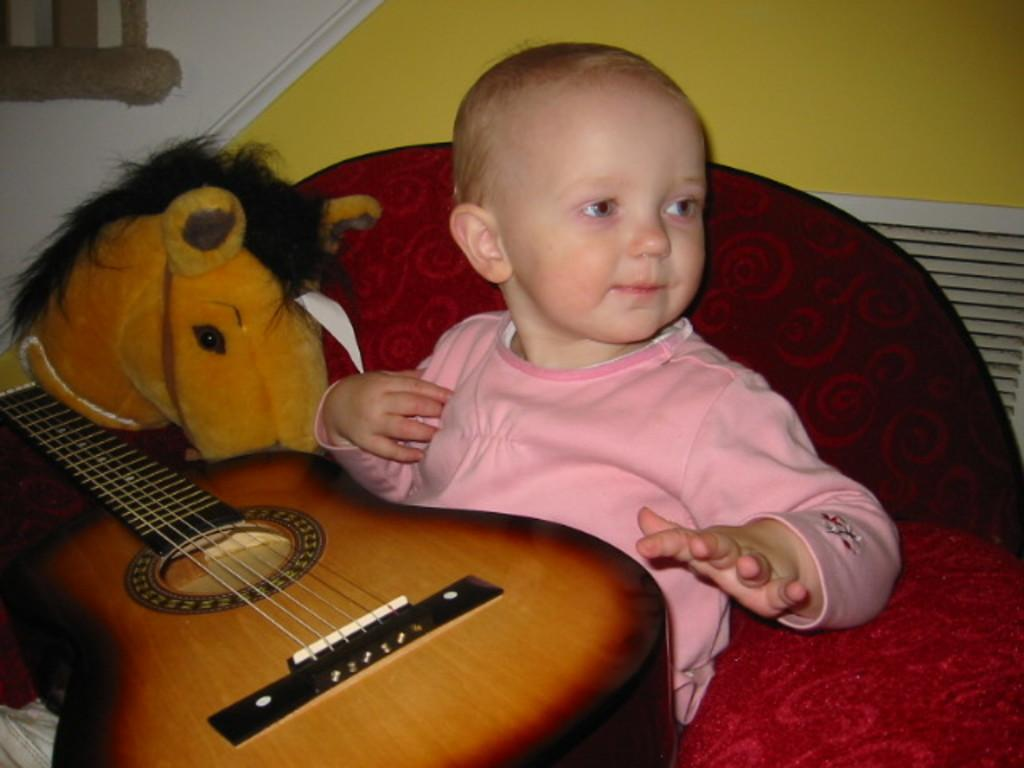What is the main subject of the image? The main subject of the image is a kid. What is the kid doing in the image? The kid is sitting on a chair and holding a guitar. Can you describe the guitar? The guitar is a toy. What can be seen in the background of the image? There is a wall in the background of the image. Is the kid driving a car in the image? No, the kid is not driving a car in the image; they are sitting on a chair and holding a toy guitar. 